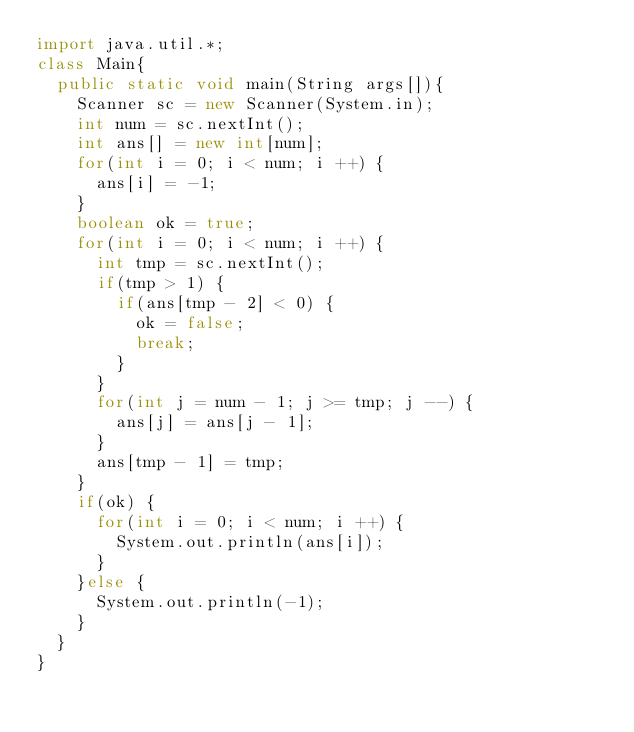Convert code to text. <code><loc_0><loc_0><loc_500><loc_500><_Java_>import java.util.*;
class Main{
  public static void main(String args[]){
    Scanner sc = new Scanner(System.in);
    int num = sc.nextInt();
    int ans[] = new int[num];
    for(int i = 0; i < num; i ++) {
      ans[i] = -1;
    }
    boolean ok = true;
    for(int i = 0; i < num; i ++) {
      int tmp = sc.nextInt();
      if(tmp > 1) {
        if(ans[tmp - 2] < 0) {
          ok = false;
          break;
        }
      }
      for(int j = num - 1; j >= tmp; j --) {
        ans[j] = ans[j - 1];
      }
      ans[tmp - 1] = tmp;
    }
    if(ok) {
      for(int i = 0; i < num; i ++) {
        System.out.println(ans[i]);
      }
    }else {
      System.out.println(-1);
    }
  }
}</code> 